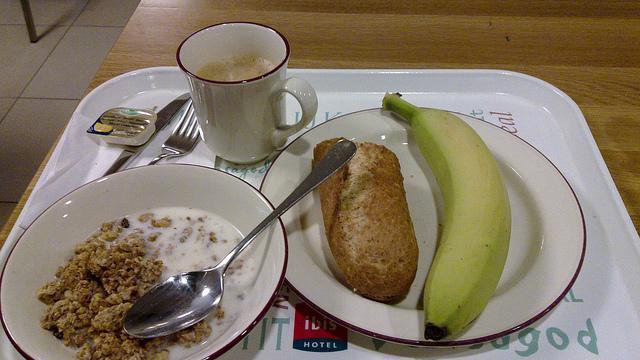How many foods are uneaten?
Give a very brief answer. 2. 